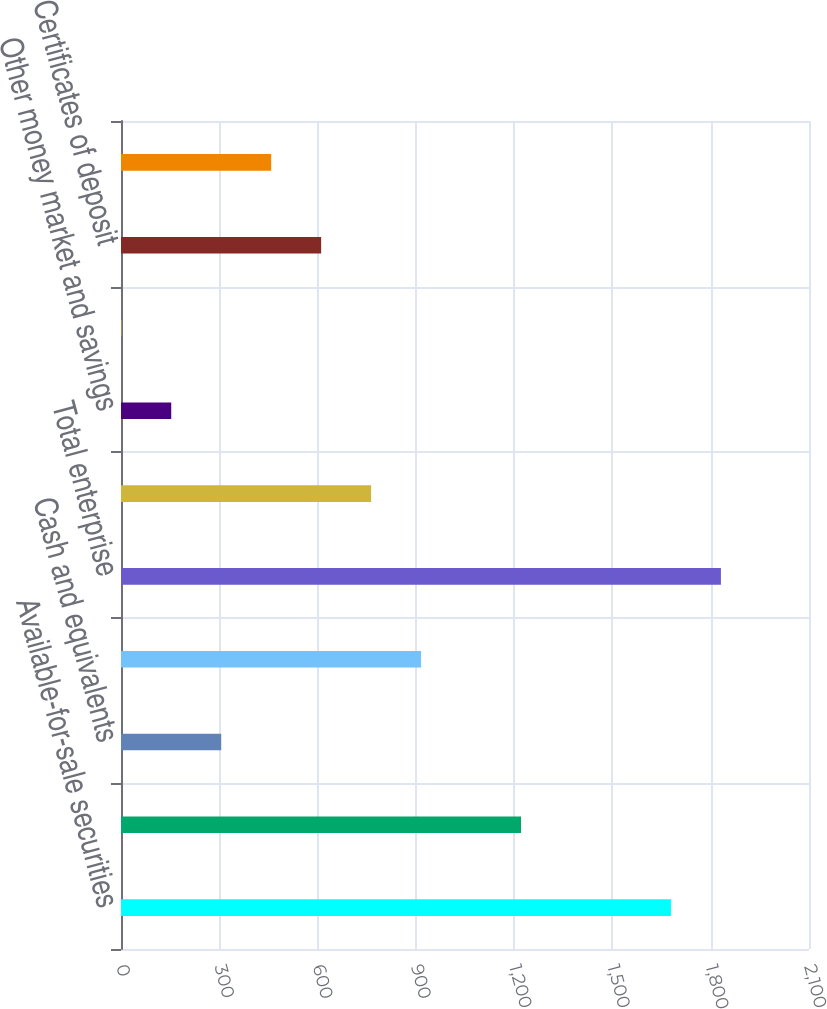Convert chart. <chart><loc_0><loc_0><loc_500><loc_500><bar_chart><fcel>Available-for-sale securities<fcel>Held-to-maturity securities<fcel>Cash and equivalents<fcel>Securities borrowed and other<fcel>Total enterprise<fcel>Complete savings deposits<fcel>Other money market and savings<fcel>Checking deposits<fcel>Certificates of deposit<fcel>Customer payables<nl><fcel>1678.63<fcel>1221.04<fcel>305.86<fcel>915.98<fcel>1831.16<fcel>763.45<fcel>153.33<fcel>0.8<fcel>610.92<fcel>458.39<nl></chart> 